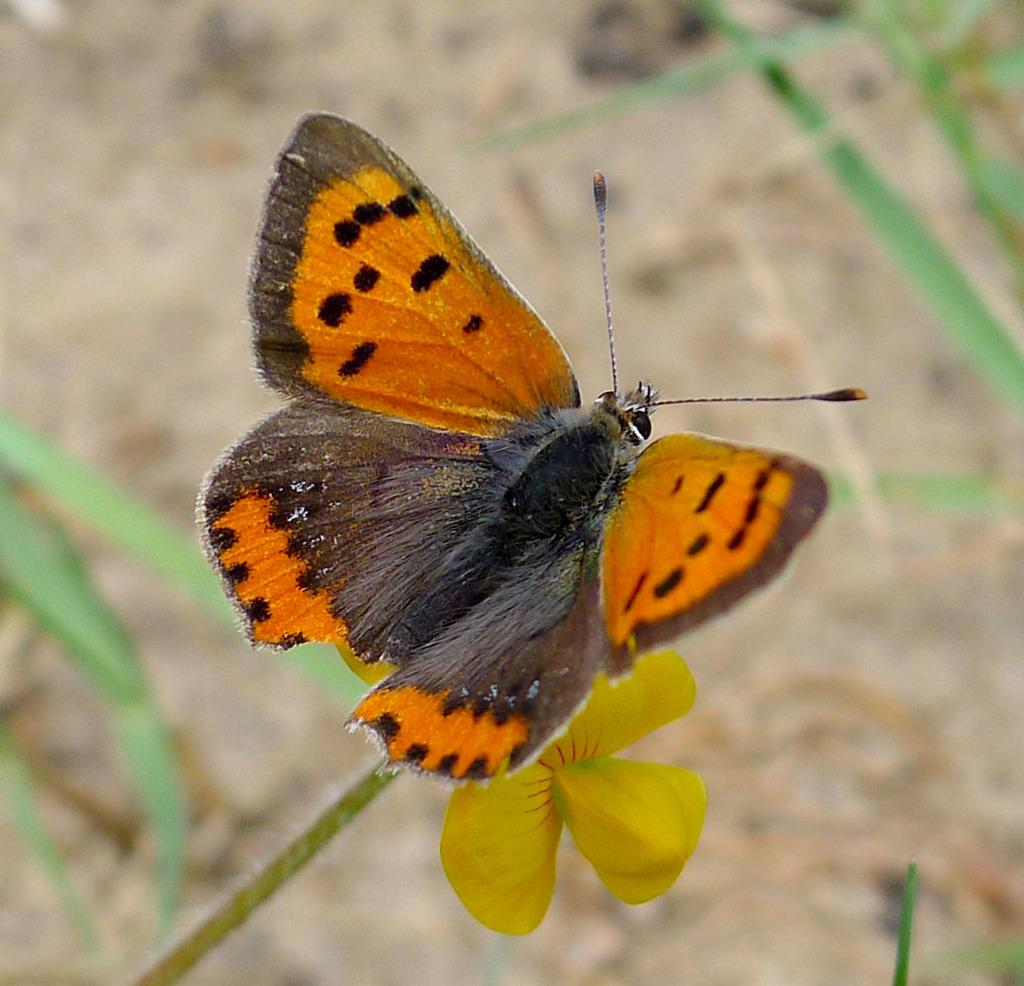What type of plant is present in the image? There is a flower in the image. Are there any animals visible in the image? Yes, there is a butterfly in the image. How would you describe the background of the image? The background of the image is blurry. What other plant part can be seen in the image? There is a leaf visible at the bottom of the image. What type of nail is being used to hold the tub in the image? There is no nail or tub present in the image. How many knots can be seen in the image? There are no knots visible in the image. 